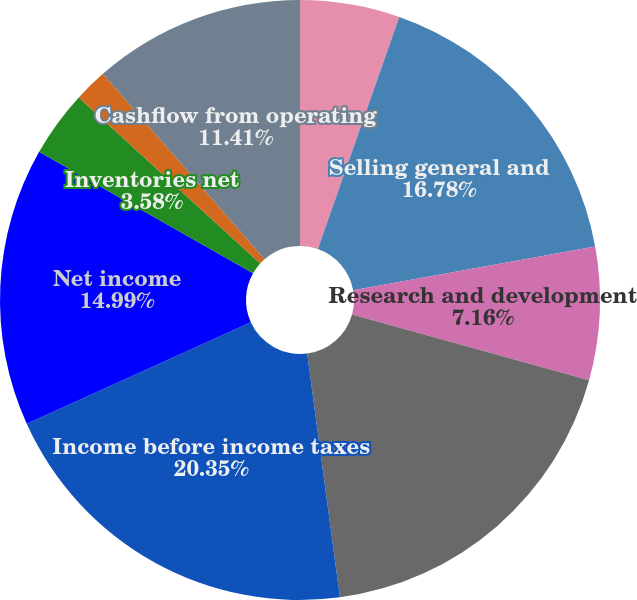Convert chart. <chart><loc_0><loc_0><loc_500><loc_500><pie_chart><fcel>Cost of sales<fcel>Selling general and<fcel>Research and development<fcel>Income from operations<fcel>Income before income taxes<fcel>Net income<fcel>Inventories net<fcel>Basic<fcel>Diluted<fcel>Cashflow from operating<nl><fcel>5.37%<fcel>16.78%<fcel>7.16%<fcel>18.57%<fcel>20.36%<fcel>14.99%<fcel>3.58%<fcel>1.79%<fcel>0.0%<fcel>11.41%<nl></chart> 